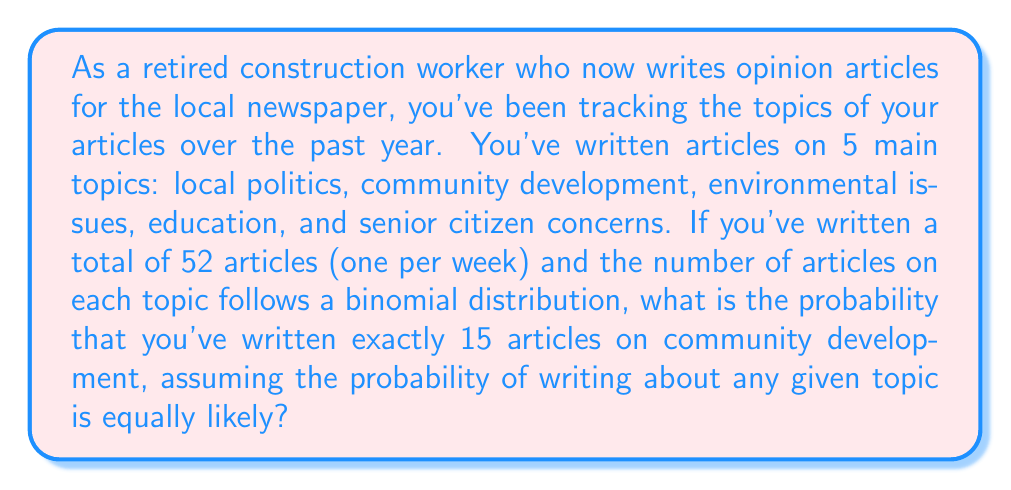Can you solve this math problem? Let's approach this step-by-step:

1) First, we need to identify the parameters of our binomial distribution:
   - $n$ = total number of trials (articles written) = 52
   - $k$ = number of successes (articles on community development) = 15
   - $p$ = probability of success on each trial

2) Since there are 5 main topics and they are equally likely, the probability of writing about any given topic is:
   $p = \frac{1}{5} = 0.2$

3) The probability of writing exactly 15 articles on community development out of 52 articles can be calculated using the binomial probability formula:

   $P(X = k) = \binom{n}{k} p^k (1-p)^{n-k}$

   Where $\binom{n}{k}$ is the binomial coefficient, calculated as:

   $\binom{n}{k} = \frac{n!}{k!(n-k)!}$

4) Let's substitute our values:

   $P(X = 15) = \binom{52}{15} (0.2)^{15} (1-0.2)^{52-15}$

5) Calculate the binomial coefficient:
   
   $\binom{52}{15} = \frac{52!}{15!(52-15)!} = \frac{52!}{15!37!} = 2,250,829,575,120$

6) Now let's calculate the full probability:

   $P(X = 15) = 2,250,829,575,120 \cdot (0.2)^{15} \cdot (0.8)^{37}$

7) Using a calculator or computer (due to the large numbers involved):

   $P(X = 15) \approx 0.1400$ or about 14.00%
Answer: The probability of writing exactly 15 articles on community development out of 52 articles, given that the probability of writing about any topic is equally likely, is approximately 0.1400 or 14.00%. 